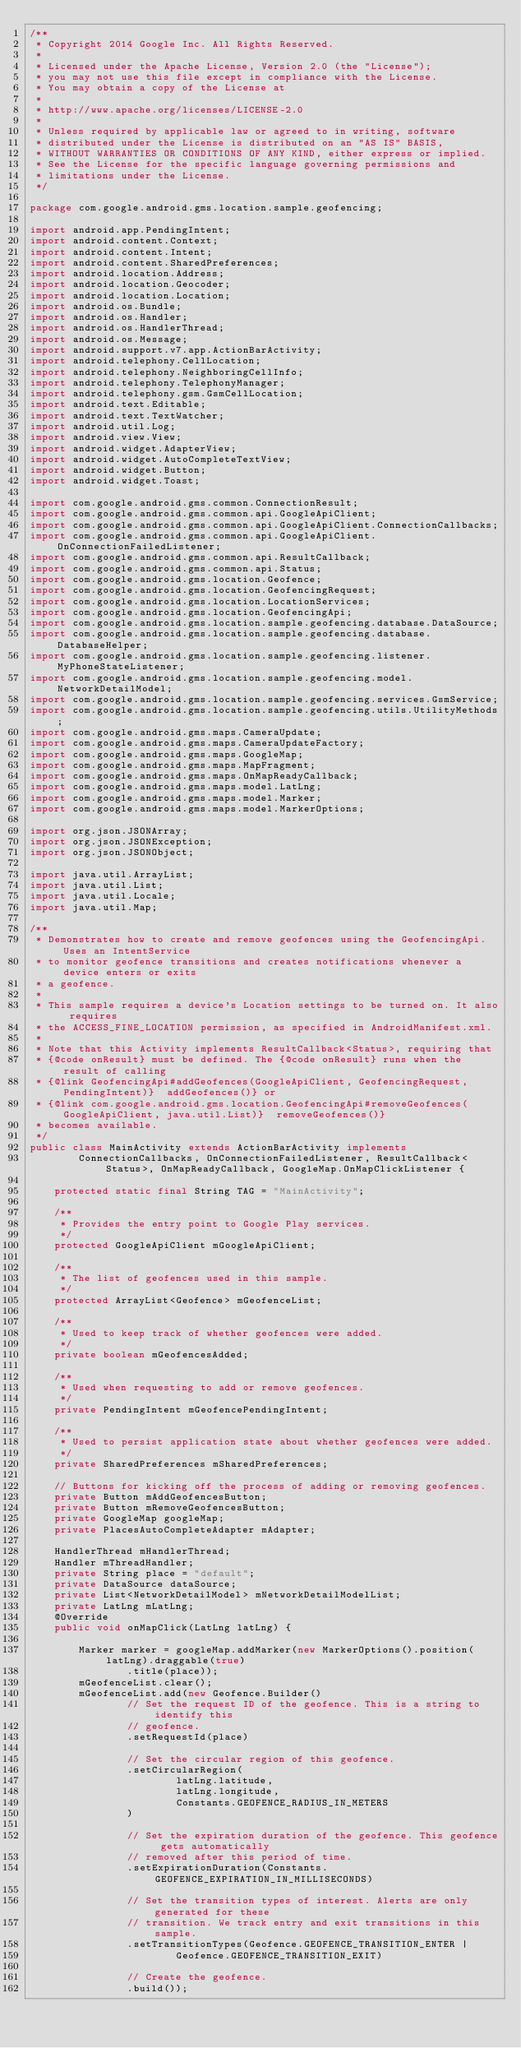Convert code to text. <code><loc_0><loc_0><loc_500><loc_500><_Java_>/**
 * Copyright 2014 Google Inc. All Rights Reserved.
 *
 * Licensed under the Apache License, Version 2.0 (the "License");
 * you may not use this file except in compliance with the License.
 * You may obtain a copy of the License at
 *
 * http://www.apache.org/licenses/LICENSE-2.0
 *
 * Unless required by applicable law or agreed to in writing, software
 * distributed under the License is distributed on an "AS IS" BASIS,
 * WITHOUT WARRANTIES OR CONDITIONS OF ANY KIND, either express or implied.
 * See the License for the specific language governing permissions and
 * limitations under the License.
 */

package com.google.android.gms.location.sample.geofencing;

import android.app.PendingIntent;
import android.content.Context;
import android.content.Intent;
import android.content.SharedPreferences;
import android.location.Address;
import android.location.Geocoder;
import android.location.Location;
import android.os.Bundle;
import android.os.Handler;
import android.os.HandlerThread;
import android.os.Message;
import android.support.v7.app.ActionBarActivity;
import android.telephony.CellLocation;
import android.telephony.NeighboringCellInfo;
import android.telephony.TelephonyManager;
import android.telephony.gsm.GsmCellLocation;
import android.text.Editable;
import android.text.TextWatcher;
import android.util.Log;
import android.view.View;
import android.widget.AdapterView;
import android.widget.AutoCompleteTextView;
import android.widget.Button;
import android.widget.Toast;

import com.google.android.gms.common.ConnectionResult;
import com.google.android.gms.common.api.GoogleApiClient;
import com.google.android.gms.common.api.GoogleApiClient.ConnectionCallbacks;
import com.google.android.gms.common.api.GoogleApiClient.OnConnectionFailedListener;
import com.google.android.gms.common.api.ResultCallback;
import com.google.android.gms.common.api.Status;
import com.google.android.gms.location.Geofence;
import com.google.android.gms.location.GeofencingRequest;
import com.google.android.gms.location.LocationServices;
import com.google.android.gms.location.GeofencingApi;
import com.google.android.gms.location.sample.geofencing.database.DataSource;
import com.google.android.gms.location.sample.geofencing.database.DatabaseHelper;
import com.google.android.gms.location.sample.geofencing.listener.MyPhoneStateListener;
import com.google.android.gms.location.sample.geofencing.model.NetworkDetailModel;
import com.google.android.gms.location.sample.geofencing.services.GsmService;
import com.google.android.gms.location.sample.geofencing.utils.UtilityMethods;
import com.google.android.gms.maps.CameraUpdate;
import com.google.android.gms.maps.CameraUpdateFactory;
import com.google.android.gms.maps.GoogleMap;
import com.google.android.gms.maps.MapFragment;
import com.google.android.gms.maps.OnMapReadyCallback;
import com.google.android.gms.maps.model.LatLng;
import com.google.android.gms.maps.model.Marker;
import com.google.android.gms.maps.model.MarkerOptions;

import org.json.JSONArray;
import org.json.JSONException;
import org.json.JSONObject;

import java.util.ArrayList;
import java.util.List;
import java.util.Locale;
import java.util.Map;

/**
 * Demonstrates how to create and remove geofences using the GeofencingApi. Uses an IntentService
 * to monitor geofence transitions and creates notifications whenever a device enters or exits
 * a geofence.
 *
 * This sample requires a device's Location settings to be turned on. It also requires
 * the ACCESS_FINE_LOCATION permission, as specified in AndroidManifest.xml.
 *
 * Note that this Activity implements ResultCallback<Status>, requiring that
 * {@code onResult} must be defined. The {@code onResult} runs when the result of calling
 * {@link GeofencingApi#addGeofences(GoogleApiClient, GeofencingRequest, PendingIntent)}  addGeofences()} or
 * {@link com.google.android.gms.location.GeofencingApi#removeGeofences(GoogleApiClient, java.util.List)}  removeGeofences()}
 * becomes available.
 */
public class MainActivity extends ActionBarActivity implements
        ConnectionCallbacks, OnConnectionFailedListener, ResultCallback<Status>, OnMapReadyCallback, GoogleMap.OnMapClickListener {

    protected static final String TAG = "MainActivity";

    /**
     * Provides the entry point to Google Play services.
     */
    protected GoogleApiClient mGoogleApiClient;

    /**
     * The list of geofences used in this sample.
     */
    protected ArrayList<Geofence> mGeofenceList;

    /**
     * Used to keep track of whether geofences were added.
     */
    private boolean mGeofencesAdded;

    /**
     * Used when requesting to add or remove geofences.
     */
    private PendingIntent mGeofencePendingIntent;

    /**
     * Used to persist application state about whether geofences were added.
     */
    private SharedPreferences mSharedPreferences;

    // Buttons for kicking off the process of adding or removing geofences.
    private Button mAddGeofencesButton;
    private Button mRemoveGeofencesButton;
    private GoogleMap googleMap;
    private PlacesAutoCompleteAdapter mAdapter;

    HandlerThread mHandlerThread;
    Handler mThreadHandler;
    private String place = "default";
    private DataSource dataSource;
    private List<NetworkDetailModel> mNetworkDetailModelList;
    private LatLng mLatLng;
    @Override
    public void onMapClick(LatLng latLng) {

        Marker marker = googleMap.addMarker(new MarkerOptions().position(latLng).draggable(true)
                .title(place));
        mGeofenceList.clear();
        mGeofenceList.add(new Geofence.Builder()
                // Set the request ID of the geofence. This is a string to identify this
                // geofence.
                .setRequestId(place)

                // Set the circular region of this geofence.
                .setCircularRegion(
                        latLng.latitude,
                        latLng.longitude,
                        Constants.GEOFENCE_RADIUS_IN_METERS
                )

                // Set the expiration duration of the geofence. This geofence gets automatically
                // removed after this period of time.
                .setExpirationDuration(Constants.GEOFENCE_EXPIRATION_IN_MILLISECONDS)

                // Set the transition types of interest. Alerts are only generated for these
                // transition. We track entry and exit transitions in this sample.
                .setTransitionTypes(Geofence.GEOFENCE_TRANSITION_ENTER |
                        Geofence.GEOFENCE_TRANSITION_EXIT)

                // Create the geofence.
                .build());</code> 